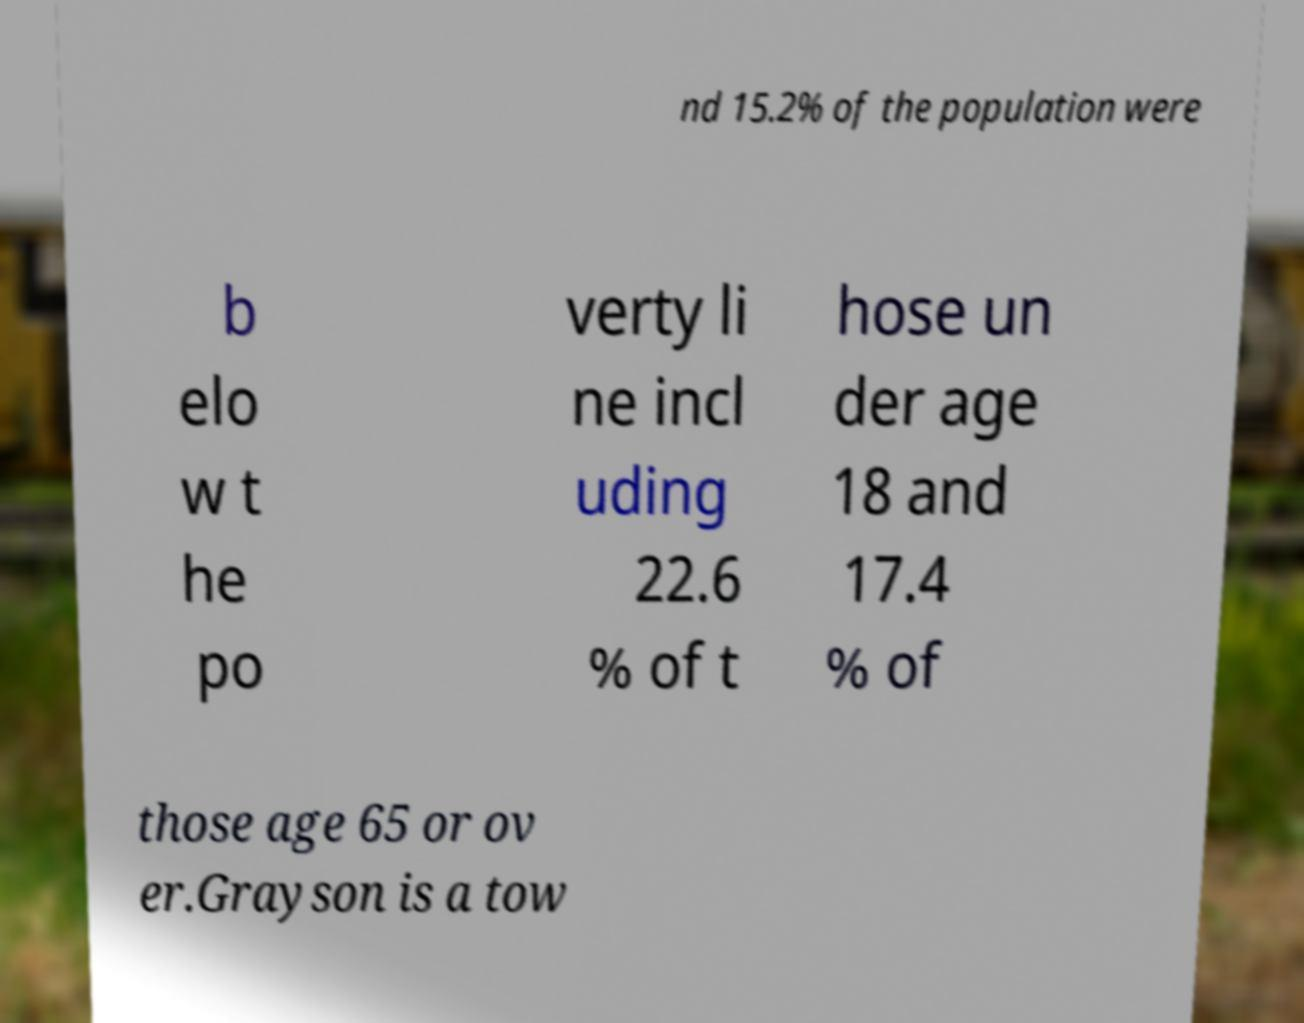For documentation purposes, I need the text within this image transcribed. Could you provide that? nd 15.2% of the population were b elo w t he po verty li ne incl uding 22.6 % of t hose un der age 18 and 17.4 % of those age 65 or ov er.Grayson is a tow 